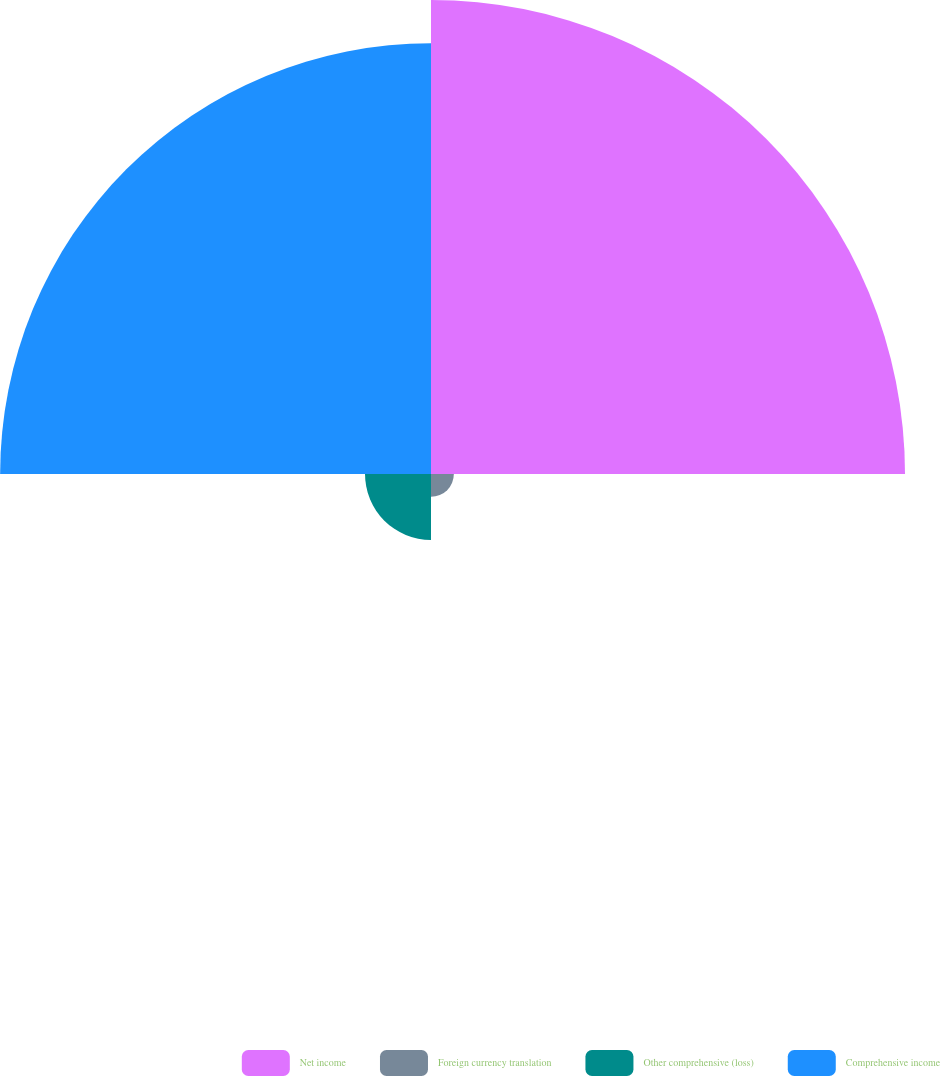Convert chart. <chart><loc_0><loc_0><loc_500><loc_500><pie_chart><fcel>Net income<fcel>Foreign currency translation<fcel>Other comprehensive (loss)<fcel>Comprehensive income<nl><fcel>47.7%<fcel>2.3%<fcel>6.64%<fcel>43.36%<nl></chart> 